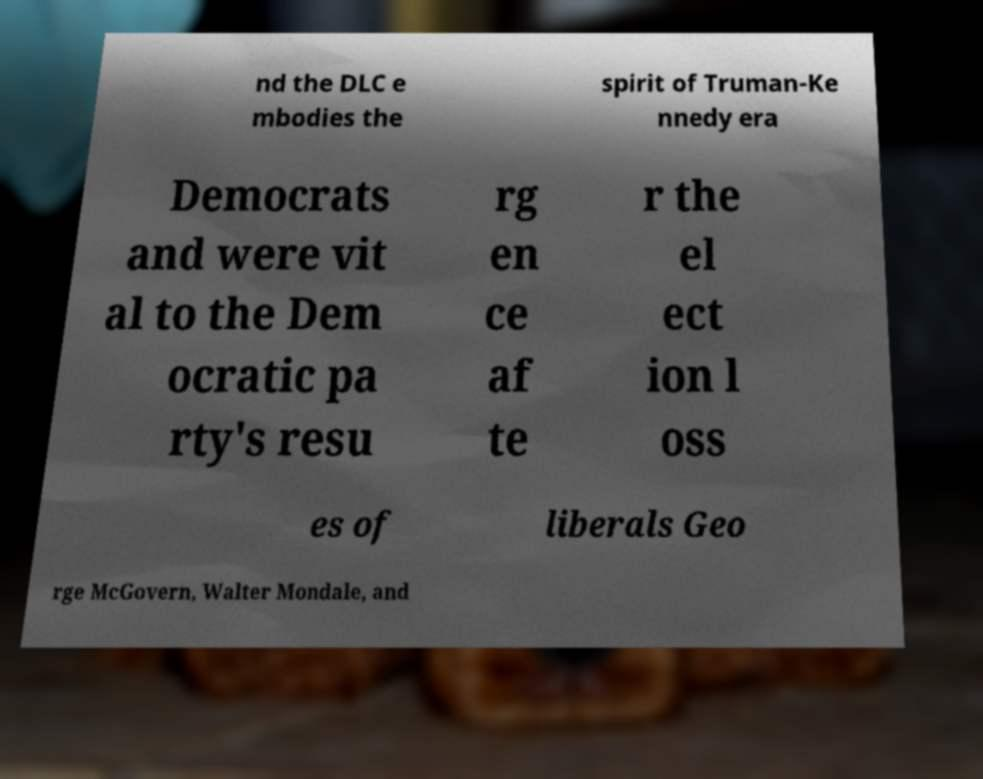Could you assist in decoding the text presented in this image and type it out clearly? nd the DLC e mbodies the spirit of Truman-Ke nnedy era Democrats and were vit al to the Dem ocratic pa rty's resu rg en ce af te r the el ect ion l oss es of liberals Geo rge McGovern, Walter Mondale, and 